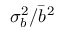Convert formula to latex. <formula><loc_0><loc_0><loc_500><loc_500>\sigma _ { b } ^ { 2 } / \bar { b } ^ { 2 }</formula> 